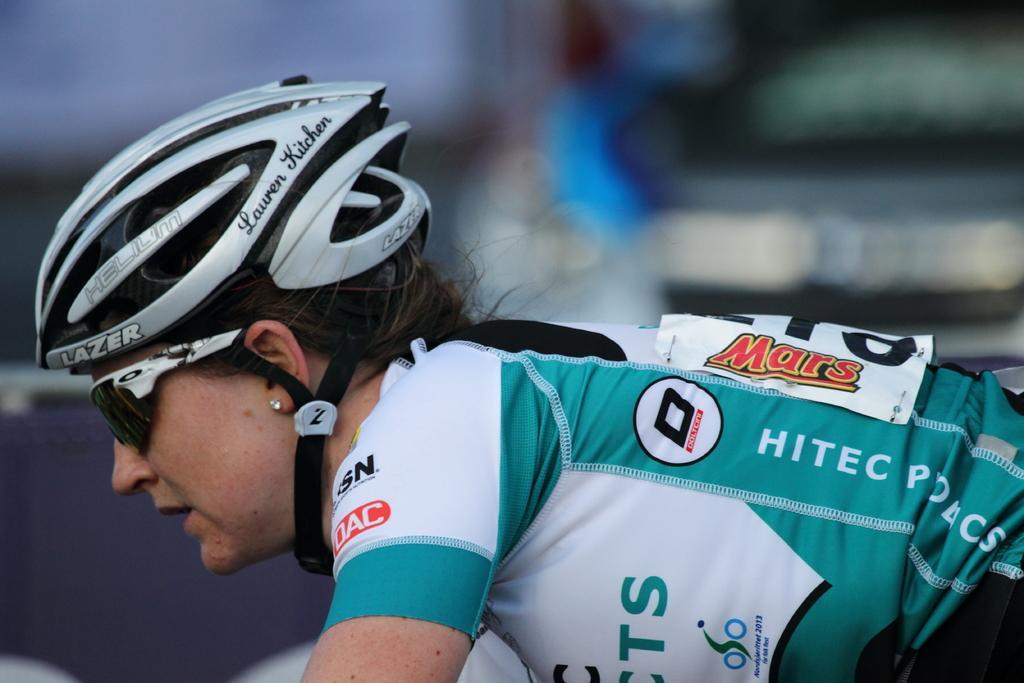Could you give a brief overview of what you see in this image? This image consists of a woman wearing a helmet and a green color jersey. The background is blurred. She is also wearing a shades. 